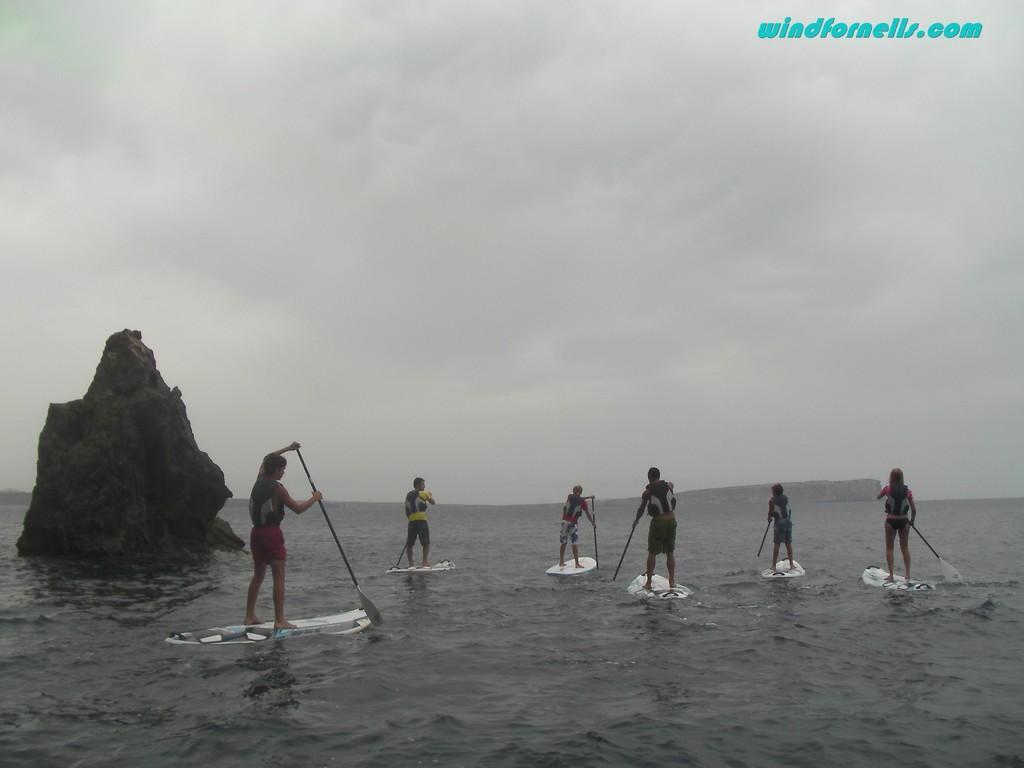How would you summarize this image in a sentence or two? In this picture, we can see a few people holding some objects on skate board in water, and we can see water, rock, and we can see the sky with clouds, we can see some text in the top right corner. 